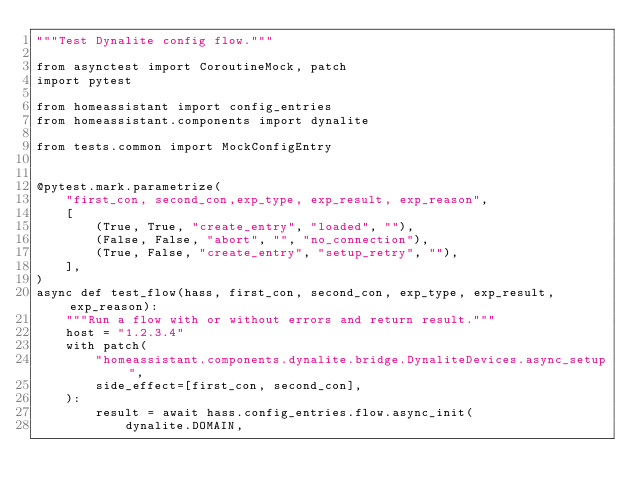Convert code to text. <code><loc_0><loc_0><loc_500><loc_500><_Python_>"""Test Dynalite config flow."""

from asynctest import CoroutineMock, patch
import pytest

from homeassistant import config_entries
from homeassistant.components import dynalite

from tests.common import MockConfigEntry


@pytest.mark.parametrize(
    "first_con, second_con,exp_type, exp_result, exp_reason",
    [
        (True, True, "create_entry", "loaded", ""),
        (False, False, "abort", "", "no_connection"),
        (True, False, "create_entry", "setup_retry", ""),
    ],
)
async def test_flow(hass, first_con, second_con, exp_type, exp_result, exp_reason):
    """Run a flow with or without errors and return result."""
    host = "1.2.3.4"
    with patch(
        "homeassistant.components.dynalite.bridge.DynaliteDevices.async_setup",
        side_effect=[first_con, second_con],
    ):
        result = await hass.config_entries.flow.async_init(
            dynalite.DOMAIN,</code> 